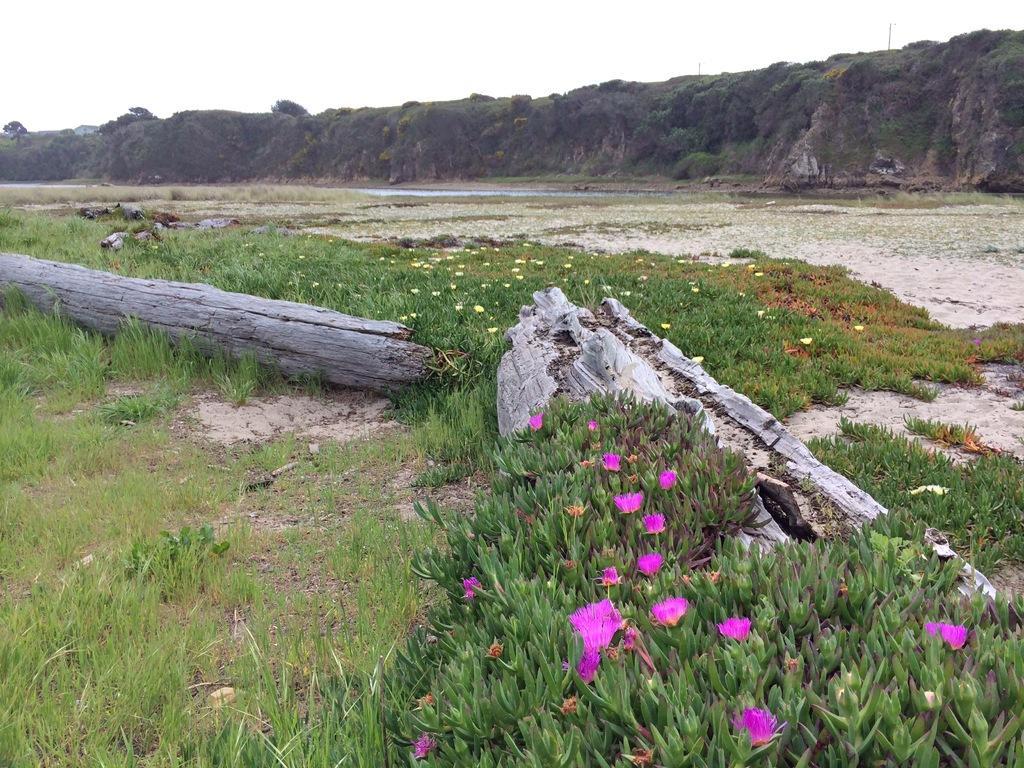Please provide a concise description of this image. In this image, we can see the ground. We can see some grass, plants with flowers and trees. We can also see some water and hills. We can see some poles and the sky. We can see some trunks of trees. 